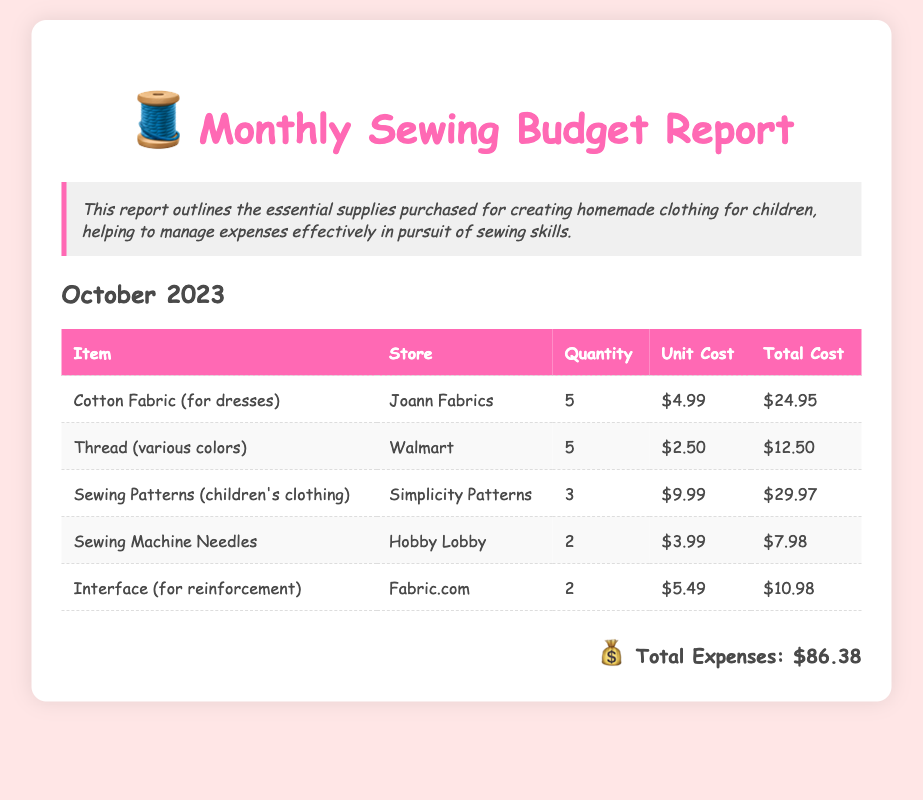What is the total cost for Cotton Fabric? The total cost for Cotton Fabric is stated in the document as $24.95.
Answer: $24.95 How many quantities of Thread were purchased? The document specifies that 5 units of Thread were purchased.
Answer: 5 Which store sold the Sewing Patterns? The Sewing Patterns were purchased from Simplicity Patterns.
Answer: Simplicity Patterns What is the unit cost of Sewing Machine Needles? The unit cost for Sewing Machine Needles is indicated in the document as $3.99.
Answer: $3.99 What are the total expenses for the month? The total expenses are summarized at the end of the document as $86.38.
Answer: $86.38 Which item had the highest total cost? The item with the highest total cost is Sewing Patterns, amounting to $29.97.
Answer: Sewing Patterns How many different items are listed in the report? The report lists a total of 5 different items.
Answer: 5 What type of report is this document? This document is a Monthly Sewing Budget Report.
Answer: Monthly Sewing Budget Report What is the purpose of this report? The purpose is to outline essential supplies purchased for homemade clothing and manage expenses.
Answer: Manage expenses 